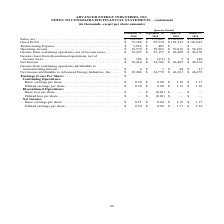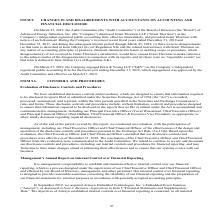According to Advanced Energy's financial document, What was the basic earnings per share of Continuing Operations  in  Quarter Ended  December? According to the financial document, $0.50. The relevant text states: "tinuing Operations: Basic earnings per share. . $ 0.50 $ 0.90 $ 1.18 $ 1.17 Diluted earnings per share . $ 0.50 $ 0.90 $ 1.17 $ 1.16 Discontinued Operatio..." Also, What was the diluted earnings per share of Continuing Operations in Quarter Ended  September? According to the financial document, $0.90. The relevant text states: "Operations: Basic earnings per share. . $ 0.50 $ 0.90 $ 1.18 $ 1.17 Diluted earnings per share . $ 0.50 $ 0.90 $ 1.17 $ 1.16 Discontinued Operations: Bas..." Also, What was the net income basic earnings per share in Quarter Ended  March? According to the financial document, $1.17. The relevant text states: "asic earnings per share. . $ 0.50 $ 0.90 $ 1.18 $ 1.17 Diluted earnings per share . $ 0.50 $ 0.90 $ 1.17 $ 1.16 Discontinued Operations: Basic loss per sh..." Also, can you calculate: What was the change in net income between Quarter Ended  September and December? Based on the calculation: $19,410-$34,786, the result is -15376 (in thousands). This is based on the information: "Net Income . $ 19,410 $ 34,786 $ 46,405 $ 46,510 Income from continuing operations attributable to noncontrolling interest . $ 4 $ Net Income . $ 19,410 $ 34,786 $ 46,405 $ 46,510 Income from continui..." The key data points involved are: 19,410, 34,786. Also, can you calculate: What was the change in Net income attributable to Advanced Energy Industries, Inc. between Quarter Ended  June and September? Based on the calculation: $34,779-$46,361, the result is -11582 (in thousands). This is based on the information: "to Advanced Energy Industries, Inc. . $ 19,406 $ 34,779 $ 46,361 $ 46,479 Earnings (Loss) Per Share: . $ Continuing Operations: Basic earnings per share. . ced Energy Industries, Inc. . $ 19,406 $ 34,..." The key data points involved are: 34,779, 46,361. Also, can you calculate: What was the percentage change in net sales between Quarter Ended  June and September? To answer this question, I need to perform calculations using the financial data. The calculation is: ($173,082-$196,032)/$196,032, which equals -11.71 (percentage). This is based on the information: "2018 2018 2018 2018 Sales, net . $ 154,161 $ 173,082 $ 196,032 $ 195,617 Gross Profit . $ 75,188 $ 85,539 $ 101,235 $ 103,645 Restructuring Expense . $ 2018 2018 2018 Sales, net . $ 154,161 $ 173,082 ..." The key data points involved are: 173,082, 196,032. 